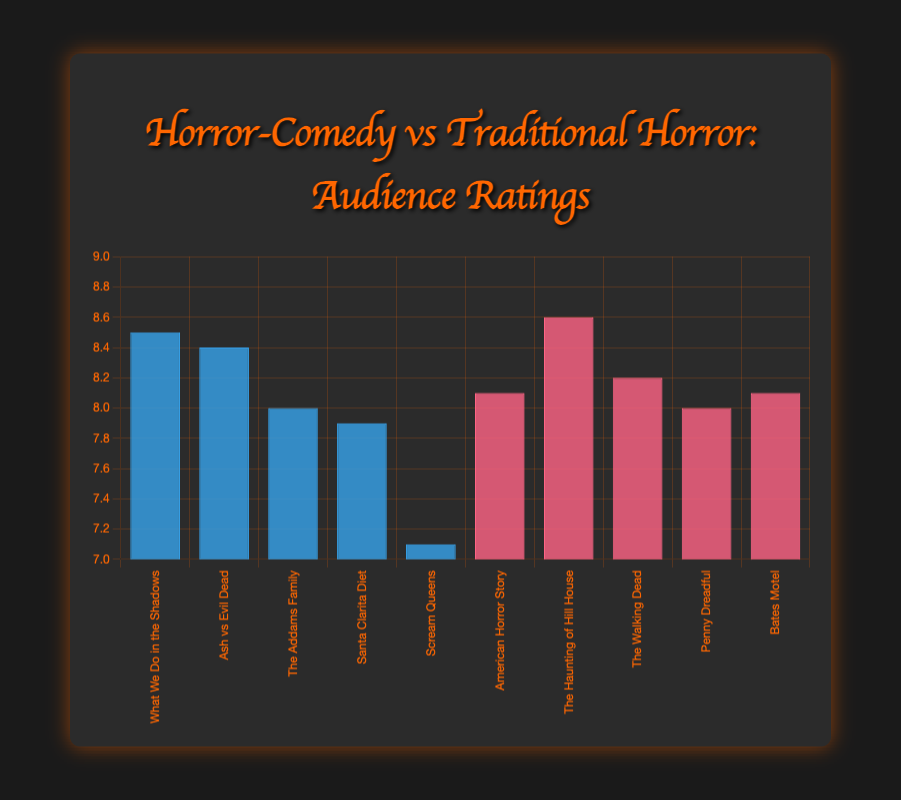What's the highest-rated horror-comedy show? To determine this, locate the tallest blue bar representing the horror-comedy shows on the chart. The show with the highest audience rating is "What We Do in the Shadows" with an 8.5 rating.
Answer: What We Do in the Shadows Which traditional horror show has a higher rating than "Ash vs Evil Dead"? "Ash vs Evil Dead" has a rating of 8.4. Identify traditional horror shows with ratings above 8.4. "The Haunting of Hill House" meets this criterion with an 8.6 rating.
Answer: The Haunting of Hill House What is the average audience rating for the horror-comedy shows? Sum the ratings of the horror-comedy shows and divide by the number of shows. The ratings are 8.5, 8.4, 8.0, 7.9, and 7.1. The sum is 39.9, and there are 5 shows. So, 39.9 / 5 = 7.98.
Answer: 7.98 Compare the ratings of "American Horror Story" and "Penny Dreadful". Which one is rated higher? Both "American Horror Story" and "Penny Dreadful" are traditional horror shows. Check their ratings: "American Horror Story" has 8.1, and "Penny Dreadful" has 8.0. So, "American Horror Story" is rated higher.
Answer: American Horror Story What is the difference in ratings between the lowest-rated horror-comedy and the lowest-rated traditional horror show? Determine the ratings of the lowest-rated shows in each category: "Scream Queens" (7.1) and compare it to the lowest-rated traditional horror show "Penny Dreadful" (8.0). The difference is 8.0 - 7.1 = 0.9.
Answer: 0.9 Which show has an audience rating of 8.2 and what type is it? Locate the bar labeled "8.2". This corresponds to the show "The Walking Dead", which is a traditional horror show.
Answer: The Walking Dead, Traditional Horror Are there more horror-comedy shows or traditional horror shows with ratings above 8.0? List all shows rated above 8.0: For horror-comedy: "What We Do in the Shadows" and "Ash vs Evil Dead". For traditional horror: "The Haunting of Hill House", "The Walking Dead", "American Horror Story", and "Bates Motel". Count them, horror-comedies have 2, traditional horrors have 4.
Answer: Traditional Horror What is the combined rating of the top-rated show from each category? Identify the highest-rated show in each category: "The Haunting of Hill House" (8.6) for traditional horror and "What We Do in the Shadows" (8.5) for horror-comedy. Combine the ratings: 8.6 + 8.5 = 17.1.
Answer: 17.1 